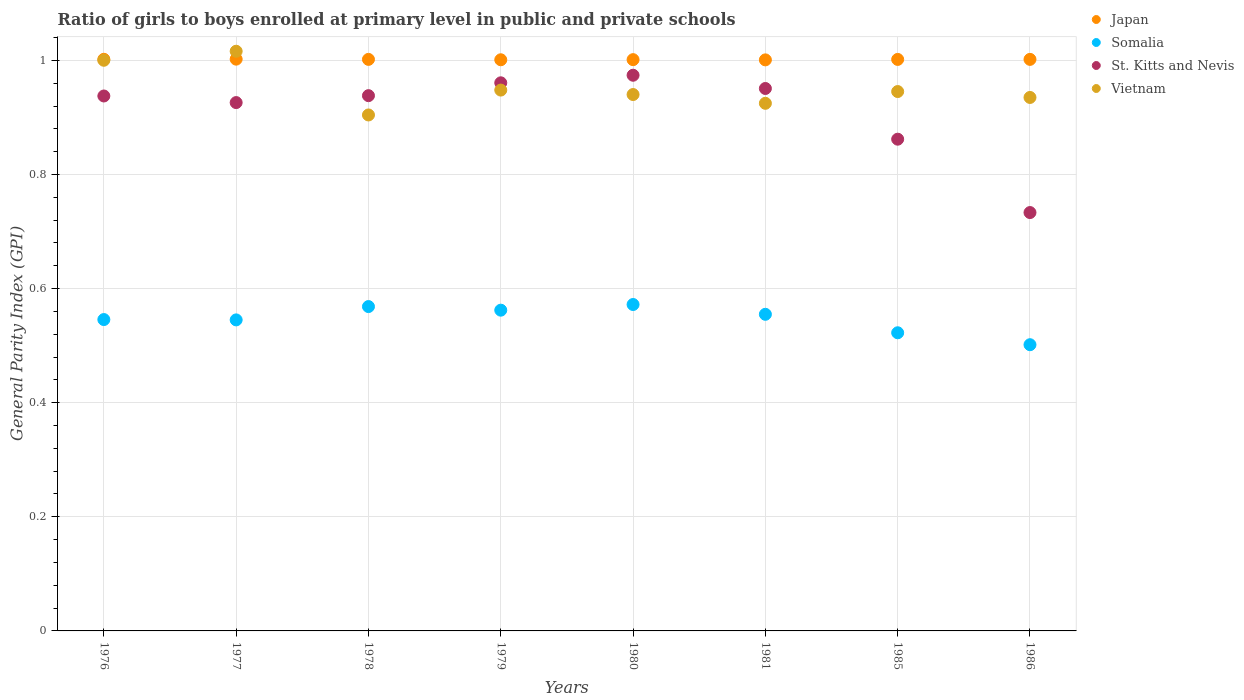How many different coloured dotlines are there?
Keep it short and to the point. 4. Is the number of dotlines equal to the number of legend labels?
Ensure brevity in your answer.  Yes. What is the general parity index in Somalia in 1986?
Give a very brief answer. 0.5. Across all years, what is the maximum general parity index in Vietnam?
Give a very brief answer. 1.02. Across all years, what is the minimum general parity index in Somalia?
Make the answer very short. 0.5. What is the total general parity index in Japan in the graph?
Ensure brevity in your answer.  8.01. What is the difference between the general parity index in Japan in 1977 and that in 1981?
Keep it short and to the point. 0. What is the difference between the general parity index in Vietnam in 1986 and the general parity index in Somalia in 1977?
Ensure brevity in your answer.  0.39. What is the average general parity index in Japan per year?
Offer a very short reply. 1. In the year 1980, what is the difference between the general parity index in Japan and general parity index in St. Kitts and Nevis?
Your answer should be very brief. 0.03. What is the ratio of the general parity index in Japan in 1980 to that in 1986?
Offer a terse response. 1. Is the difference between the general parity index in Japan in 1977 and 1986 greater than the difference between the general parity index in St. Kitts and Nevis in 1977 and 1986?
Offer a terse response. No. What is the difference between the highest and the second highest general parity index in Vietnam?
Keep it short and to the point. 0.02. What is the difference between the highest and the lowest general parity index in Vietnam?
Give a very brief answer. 0.11. Is the general parity index in Japan strictly greater than the general parity index in Vietnam over the years?
Make the answer very short. No. How many dotlines are there?
Keep it short and to the point. 4. Are the values on the major ticks of Y-axis written in scientific E-notation?
Your answer should be compact. No. Where does the legend appear in the graph?
Ensure brevity in your answer.  Top right. How are the legend labels stacked?
Ensure brevity in your answer.  Vertical. What is the title of the graph?
Your response must be concise. Ratio of girls to boys enrolled at primary level in public and private schools. Does "Mozambique" appear as one of the legend labels in the graph?
Offer a terse response. No. What is the label or title of the X-axis?
Offer a terse response. Years. What is the label or title of the Y-axis?
Keep it short and to the point. General Parity Index (GPI). What is the General Parity Index (GPI) of Japan in 1976?
Provide a short and direct response. 1. What is the General Parity Index (GPI) in Somalia in 1976?
Your answer should be compact. 0.55. What is the General Parity Index (GPI) in St. Kitts and Nevis in 1976?
Your response must be concise. 0.94. What is the General Parity Index (GPI) of Vietnam in 1976?
Your response must be concise. 1. What is the General Parity Index (GPI) of Japan in 1977?
Provide a succinct answer. 1. What is the General Parity Index (GPI) in Somalia in 1977?
Your answer should be very brief. 0.55. What is the General Parity Index (GPI) of St. Kitts and Nevis in 1977?
Offer a terse response. 0.93. What is the General Parity Index (GPI) of Vietnam in 1977?
Provide a succinct answer. 1.02. What is the General Parity Index (GPI) of Japan in 1978?
Keep it short and to the point. 1. What is the General Parity Index (GPI) in Somalia in 1978?
Your answer should be compact. 0.57. What is the General Parity Index (GPI) of St. Kitts and Nevis in 1978?
Provide a short and direct response. 0.94. What is the General Parity Index (GPI) of Vietnam in 1978?
Keep it short and to the point. 0.9. What is the General Parity Index (GPI) of Japan in 1979?
Make the answer very short. 1. What is the General Parity Index (GPI) of Somalia in 1979?
Give a very brief answer. 0.56. What is the General Parity Index (GPI) of St. Kitts and Nevis in 1979?
Provide a succinct answer. 0.96. What is the General Parity Index (GPI) of Vietnam in 1979?
Provide a short and direct response. 0.95. What is the General Parity Index (GPI) in Japan in 1980?
Offer a very short reply. 1. What is the General Parity Index (GPI) of Somalia in 1980?
Make the answer very short. 0.57. What is the General Parity Index (GPI) in St. Kitts and Nevis in 1980?
Your answer should be very brief. 0.97. What is the General Parity Index (GPI) of Vietnam in 1980?
Offer a terse response. 0.94. What is the General Parity Index (GPI) in Japan in 1981?
Provide a succinct answer. 1. What is the General Parity Index (GPI) of Somalia in 1981?
Your answer should be compact. 0.55. What is the General Parity Index (GPI) in St. Kitts and Nevis in 1981?
Keep it short and to the point. 0.95. What is the General Parity Index (GPI) in Vietnam in 1981?
Keep it short and to the point. 0.92. What is the General Parity Index (GPI) in Japan in 1985?
Provide a short and direct response. 1. What is the General Parity Index (GPI) of Somalia in 1985?
Keep it short and to the point. 0.52. What is the General Parity Index (GPI) of St. Kitts and Nevis in 1985?
Your response must be concise. 0.86. What is the General Parity Index (GPI) of Vietnam in 1985?
Offer a very short reply. 0.95. What is the General Parity Index (GPI) of Japan in 1986?
Your answer should be very brief. 1. What is the General Parity Index (GPI) in Somalia in 1986?
Make the answer very short. 0.5. What is the General Parity Index (GPI) of St. Kitts and Nevis in 1986?
Your answer should be compact. 0.73. What is the General Parity Index (GPI) in Vietnam in 1986?
Make the answer very short. 0.93. Across all years, what is the maximum General Parity Index (GPI) of Japan?
Keep it short and to the point. 1. Across all years, what is the maximum General Parity Index (GPI) in Somalia?
Your response must be concise. 0.57. Across all years, what is the maximum General Parity Index (GPI) of St. Kitts and Nevis?
Your response must be concise. 0.97. Across all years, what is the maximum General Parity Index (GPI) of Vietnam?
Your answer should be very brief. 1.02. Across all years, what is the minimum General Parity Index (GPI) in Japan?
Your response must be concise. 1. Across all years, what is the minimum General Parity Index (GPI) in Somalia?
Your answer should be very brief. 0.5. Across all years, what is the minimum General Parity Index (GPI) in St. Kitts and Nevis?
Your answer should be compact. 0.73. Across all years, what is the minimum General Parity Index (GPI) of Vietnam?
Your response must be concise. 0.9. What is the total General Parity Index (GPI) of Japan in the graph?
Keep it short and to the point. 8.01. What is the total General Parity Index (GPI) in Somalia in the graph?
Provide a short and direct response. 4.37. What is the total General Parity Index (GPI) of St. Kitts and Nevis in the graph?
Keep it short and to the point. 7.28. What is the total General Parity Index (GPI) in Vietnam in the graph?
Give a very brief answer. 7.61. What is the difference between the General Parity Index (GPI) in Japan in 1976 and that in 1977?
Offer a terse response. -0. What is the difference between the General Parity Index (GPI) of Somalia in 1976 and that in 1977?
Your answer should be compact. 0. What is the difference between the General Parity Index (GPI) of St. Kitts and Nevis in 1976 and that in 1977?
Provide a short and direct response. 0.01. What is the difference between the General Parity Index (GPI) in Vietnam in 1976 and that in 1977?
Ensure brevity in your answer.  -0.02. What is the difference between the General Parity Index (GPI) of Japan in 1976 and that in 1978?
Your response must be concise. 0. What is the difference between the General Parity Index (GPI) in Somalia in 1976 and that in 1978?
Offer a very short reply. -0.02. What is the difference between the General Parity Index (GPI) of St. Kitts and Nevis in 1976 and that in 1978?
Ensure brevity in your answer.  -0. What is the difference between the General Parity Index (GPI) in Vietnam in 1976 and that in 1978?
Provide a succinct answer. 0.1. What is the difference between the General Parity Index (GPI) of Japan in 1976 and that in 1979?
Offer a terse response. 0. What is the difference between the General Parity Index (GPI) in Somalia in 1976 and that in 1979?
Keep it short and to the point. -0.02. What is the difference between the General Parity Index (GPI) in St. Kitts and Nevis in 1976 and that in 1979?
Make the answer very short. -0.02. What is the difference between the General Parity Index (GPI) of Vietnam in 1976 and that in 1979?
Your response must be concise. 0.05. What is the difference between the General Parity Index (GPI) in Japan in 1976 and that in 1980?
Make the answer very short. 0. What is the difference between the General Parity Index (GPI) of Somalia in 1976 and that in 1980?
Keep it short and to the point. -0.03. What is the difference between the General Parity Index (GPI) in St. Kitts and Nevis in 1976 and that in 1980?
Give a very brief answer. -0.04. What is the difference between the General Parity Index (GPI) in Vietnam in 1976 and that in 1980?
Offer a very short reply. 0.06. What is the difference between the General Parity Index (GPI) in Somalia in 1976 and that in 1981?
Keep it short and to the point. -0.01. What is the difference between the General Parity Index (GPI) in St. Kitts and Nevis in 1976 and that in 1981?
Your answer should be very brief. -0.01. What is the difference between the General Parity Index (GPI) in Vietnam in 1976 and that in 1981?
Your answer should be compact. 0.08. What is the difference between the General Parity Index (GPI) of Japan in 1976 and that in 1985?
Give a very brief answer. 0. What is the difference between the General Parity Index (GPI) in Somalia in 1976 and that in 1985?
Give a very brief answer. 0.02. What is the difference between the General Parity Index (GPI) of St. Kitts and Nevis in 1976 and that in 1985?
Offer a terse response. 0.08. What is the difference between the General Parity Index (GPI) of Vietnam in 1976 and that in 1985?
Provide a short and direct response. 0.05. What is the difference between the General Parity Index (GPI) of Japan in 1976 and that in 1986?
Offer a terse response. 0. What is the difference between the General Parity Index (GPI) in Somalia in 1976 and that in 1986?
Provide a succinct answer. 0.04. What is the difference between the General Parity Index (GPI) of St. Kitts and Nevis in 1976 and that in 1986?
Provide a short and direct response. 0.2. What is the difference between the General Parity Index (GPI) of Vietnam in 1976 and that in 1986?
Give a very brief answer. 0.07. What is the difference between the General Parity Index (GPI) in Japan in 1977 and that in 1978?
Give a very brief answer. 0. What is the difference between the General Parity Index (GPI) in Somalia in 1977 and that in 1978?
Your answer should be compact. -0.02. What is the difference between the General Parity Index (GPI) in St. Kitts and Nevis in 1977 and that in 1978?
Provide a succinct answer. -0.01. What is the difference between the General Parity Index (GPI) in Vietnam in 1977 and that in 1978?
Provide a succinct answer. 0.11. What is the difference between the General Parity Index (GPI) in Japan in 1977 and that in 1979?
Your answer should be compact. 0. What is the difference between the General Parity Index (GPI) in Somalia in 1977 and that in 1979?
Your answer should be compact. -0.02. What is the difference between the General Parity Index (GPI) of St. Kitts and Nevis in 1977 and that in 1979?
Give a very brief answer. -0.03. What is the difference between the General Parity Index (GPI) of Vietnam in 1977 and that in 1979?
Keep it short and to the point. 0.07. What is the difference between the General Parity Index (GPI) in Japan in 1977 and that in 1980?
Give a very brief answer. 0. What is the difference between the General Parity Index (GPI) in Somalia in 1977 and that in 1980?
Your answer should be compact. -0.03. What is the difference between the General Parity Index (GPI) in St. Kitts and Nevis in 1977 and that in 1980?
Provide a short and direct response. -0.05. What is the difference between the General Parity Index (GPI) in Vietnam in 1977 and that in 1980?
Your response must be concise. 0.08. What is the difference between the General Parity Index (GPI) of Japan in 1977 and that in 1981?
Provide a short and direct response. 0. What is the difference between the General Parity Index (GPI) of Somalia in 1977 and that in 1981?
Provide a succinct answer. -0.01. What is the difference between the General Parity Index (GPI) of St. Kitts and Nevis in 1977 and that in 1981?
Your answer should be compact. -0.02. What is the difference between the General Parity Index (GPI) in Vietnam in 1977 and that in 1981?
Offer a very short reply. 0.09. What is the difference between the General Parity Index (GPI) in Somalia in 1977 and that in 1985?
Keep it short and to the point. 0.02. What is the difference between the General Parity Index (GPI) in St. Kitts and Nevis in 1977 and that in 1985?
Provide a short and direct response. 0.06. What is the difference between the General Parity Index (GPI) in Vietnam in 1977 and that in 1985?
Your answer should be compact. 0.07. What is the difference between the General Parity Index (GPI) in Somalia in 1977 and that in 1986?
Your response must be concise. 0.04. What is the difference between the General Parity Index (GPI) in St. Kitts and Nevis in 1977 and that in 1986?
Make the answer very short. 0.19. What is the difference between the General Parity Index (GPI) of Vietnam in 1977 and that in 1986?
Ensure brevity in your answer.  0.08. What is the difference between the General Parity Index (GPI) in Japan in 1978 and that in 1979?
Give a very brief answer. 0. What is the difference between the General Parity Index (GPI) of Somalia in 1978 and that in 1979?
Provide a short and direct response. 0.01. What is the difference between the General Parity Index (GPI) in St. Kitts and Nevis in 1978 and that in 1979?
Your answer should be compact. -0.02. What is the difference between the General Parity Index (GPI) of Vietnam in 1978 and that in 1979?
Provide a succinct answer. -0.04. What is the difference between the General Parity Index (GPI) of Somalia in 1978 and that in 1980?
Your answer should be compact. -0. What is the difference between the General Parity Index (GPI) of St. Kitts and Nevis in 1978 and that in 1980?
Provide a succinct answer. -0.04. What is the difference between the General Parity Index (GPI) of Vietnam in 1978 and that in 1980?
Provide a succinct answer. -0.04. What is the difference between the General Parity Index (GPI) of Japan in 1978 and that in 1981?
Your answer should be compact. 0. What is the difference between the General Parity Index (GPI) in Somalia in 1978 and that in 1981?
Offer a terse response. 0.01. What is the difference between the General Parity Index (GPI) of St. Kitts and Nevis in 1978 and that in 1981?
Keep it short and to the point. -0.01. What is the difference between the General Parity Index (GPI) in Vietnam in 1978 and that in 1981?
Offer a terse response. -0.02. What is the difference between the General Parity Index (GPI) in Somalia in 1978 and that in 1985?
Provide a succinct answer. 0.05. What is the difference between the General Parity Index (GPI) of St. Kitts and Nevis in 1978 and that in 1985?
Provide a short and direct response. 0.08. What is the difference between the General Parity Index (GPI) of Vietnam in 1978 and that in 1985?
Your answer should be compact. -0.04. What is the difference between the General Parity Index (GPI) in Japan in 1978 and that in 1986?
Give a very brief answer. -0. What is the difference between the General Parity Index (GPI) of Somalia in 1978 and that in 1986?
Keep it short and to the point. 0.07. What is the difference between the General Parity Index (GPI) of St. Kitts and Nevis in 1978 and that in 1986?
Offer a terse response. 0.2. What is the difference between the General Parity Index (GPI) in Vietnam in 1978 and that in 1986?
Provide a succinct answer. -0.03. What is the difference between the General Parity Index (GPI) of Japan in 1979 and that in 1980?
Offer a very short reply. -0. What is the difference between the General Parity Index (GPI) of Somalia in 1979 and that in 1980?
Provide a succinct answer. -0.01. What is the difference between the General Parity Index (GPI) in St. Kitts and Nevis in 1979 and that in 1980?
Your answer should be very brief. -0.01. What is the difference between the General Parity Index (GPI) of Vietnam in 1979 and that in 1980?
Your answer should be compact. 0.01. What is the difference between the General Parity Index (GPI) in Japan in 1979 and that in 1981?
Make the answer very short. 0. What is the difference between the General Parity Index (GPI) of Somalia in 1979 and that in 1981?
Ensure brevity in your answer.  0.01. What is the difference between the General Parity Index (GPI) in St. Kitts and Nevis in 1979 and that in 1981?
Your answer should be very brief. 0.01. What is the difference between the General Parity Index (GPI) of Vietnam in 1979 and that in 1981?
Your answer should be very brief. 0.02. What is the difference between the General Parity Index (GPI) of Japan in 1979 and that in 1985?
Make the answer very short. -0. What is the difference between the General Parity Index (GPI) in Somalia in 1979 and that in 1985?
Provide a short and direct response. 0.04. What is the difference between the General Parity Index (GPI) in St. Kitts and Nevis in 1979 and that in 1985?
Offer a terse response. 0.1. What is the difference between the General Parity Index (GPI) of Vietnam in 1979 and that in 1985?
Keep it short and to the point. 0. What is the difference between the General Parity Index (GPI) in Japan in 1979 and that in 1986?
Your answer should be very brief. -0. What is the difference between the General Parity Index (GPI) in Somalia in 1979 and that in 1986?
Make the answer very short. 0.06. What is the difference between the General Parity Index (GPI) of St. Kitts and Nevis in 1979 and that in 1986?
Give a very brief answer. 0.23. What is the difference between the General Parity Index (GPI) of Vietnam in 1979 and that in 1986?
Make the answer very short. 0.01. What is the difference between the General Parity Index (GPI) of Somalia in 1980 and that in 1981?
Make the answer very short. 0.02. What is the difference between the General Parity Index (GPI) of St. Kitts and Nevis in 1980 and that in 1981?
Your response must be concise. 0.02. What is the difference between the General Parity Index (GPI) of Vietnam in 1980 and that in 1981?
Give a very brief answer. 0.02. What is the difference between the General Parity Index (GPI) of Japan in 1980 and that in 1985?
Ensure brevity in your answer.  -0. What is the difference between the General Parity Index (GPI) in Somalia in 1980 and that in 1985?
Keep it short and to the point. 0.05. What is the difference between the General Parity Index (GPI) in St. Kitts and Nevis in 1980 and that in 1985?
Ensure brevity in your answer.  0.11. What is the difference between the General Parity Index (GPI) in Vietnam in 1980 and that in 1985?
Offer a terse response. -0.01. What is the difference between the General Parity Index (GPI) of Japan in 1980 and that in 1986?
Ensure brevity in your answer.  -0. What is the difference between the General Parity Index (GPI) of Somalia in 1980 and that in 1986?
Offer a terse response. 0.07. What is the difference between the General Parity Index (GPI) in St. Kitts and Nevis in 1980 and that in 1986?
Your answer should be very brief. 0.24. What is the difference between the General Parity Index (GPI) in Vietnam in 1980 and that in 1986?
Make the answer very short. 0.01. What is the difference between the General Parity Index (GPI) of Japan in 1981 and that in 1985?
Your response must be concise. -0. What is the difference between the General Parity Index (GPI) in Somalia in 1981 and that in 1985?
Provide a short and direct response. 0.03. What is the difference between the General Parity Index (GPI) in St. Kitts and Nevis in 1981 and that in 1985?
Keep it short and to the point. 0.09. What is the difference between the General Parity Index (GPI) of Vietnam in 1981 and that in 1985?
Your response must be concise. -0.02. What is the difference between the General Parity Index (GPI) in Japan in 1981 and that in 1986?
Provide a succinct answer. -0. What is the difference between the General Parity Index (GPI) of Somalia in 1981 and that in 1986?
Offer a very short reply. 0.05. What is the difference between the General Parity Index (GPI) of St. Kitts and Nevis in 1981 and that in 1986?
Keep it short and to the point. 0.22. What is the difference between the General Parity Index (GPI) in Vietnam in 1981 and that in 1986?
Keep it short and to the point. -0.01. What is the difference between the General Parity Index (GPI) in Japan in 1985 and that in 1986?
Give a very brief answer. -0. What is the difference between the General Parity Index (GPI) of Somalia in 1985 and that in 1986?
Give a very brief answer. 0.02. What is the difference between the General Parity Index (GPI) of St. Kitts and Nevis in 1985 and that in 1986?
Provide a succinct answer. 0.13. What is the difference between the General Parity Index (GPI) of Vietnam in 1985 and that in 1986?
Your answer should be very brief. 0.01. What is the difference between the General Parity Index (GPI) in Japan in 1976 and the General Parity Index (GPI) in Somalia in 1977?
Give a very brief answer. 0.46. What is the difference between the General Parity Index (GPI) of Japan in 1976 and the General Parity Index (GPI) of St. Kitts and Nevis in 1977?
Your response must be concise. 0.08. What is the difference between the General Parity Index (GPI) of Japan in 1976 and the General Parity Index (GPI) of Vietnam in 1977?
Provide a short and direct response. -0.01. What is the difference between the General Parity Index (GPI) of Somalia in 1976 and the General Parity Index (GPI) of St. Kitts and Nevis in 1977?
Give a very brief answer. -0.38. What is the difference between the General Parity Index (GPI) in Somalia in 1976 and the General Parity Index (GPI) in Vietnam in 1977?
Keep it short and to the point. -0.47. What is the difference between the General Parity Index (GPI) in St. Kitts and Nevis in 1976 and the General Parity Index (GPI) in Vietnam in 1977?
Offer a very short reply. -0.08. What is the difference between the General Parity Index (GPI) in Japan in 1976 and the General Parity Index (GPI) in Somalia in 1978?
Provide a short and direct response. 0.43. What is the difference between the General Parity Index (GPI) of Japan in 1976 and the General Parity Index (GPI) of St. Kitts and Nevis in 1978?
Your response must be concise. 0.06. What is the difference between the General Parity Index (GPI) in Japan in 1976 and the General Parity Index (GPI) in Vietnam in 1978?
Your answer should be very brief. 0.1. What is the difference between the General Parity Index (GPI) of Somalia in 1976 and the General Parity Index (GPI) of St. Kitts and Nevis in 1978?
Provide a short and direct response. -0.39. What is the difference between the General Parity Index (GPI) in Somalia in 1976 and the General Parity Index (GPI) in Vietnam in 1978?
Give a very brief answer. -0.36. What is the difference between the General Parity Index (GPI) of St. Kitts and Nevis in 1976 and the General Parity Index (GPI) of Vietnam in 1978?
Keep it short and to the point. 0.03. What is the difference between the General Parity Index (GPI) in Japan in 1976 and the General Parity Index (GPI) in Somalia in 1979?
Provide a succinct answer. 0.44. What is the difference between the General Parity Index (GPI) of Japan in 1976 and the General Parity Index (GPI) of St. Kitts and Nevis in 1979?
Ensure brevity in your answer.  0.04. What is the difference between the General Parity Index (GPI) in Japan in 1976 and the General Parity Index (GPI) in Vietnam in 1979?
Your response must be concise. 0.05. What is the difference between the General Parity Index (GPI) in Somalia in 1976 and the General Parity Index (GPI) in St. Kitts and Nevis in 1979?
Keep it short and to the point. -0.41. What is the difference between the General Parity Index (GPI) of Somalia in 1976 and the General Parity Index (GPI) of Vietnam in 1979?
Provide a short and direct response. -0.4. What is the difference between the General Parity Index (GPI) in St. Kitts and Nevis in 1976 and the General Parity Index (GPI) in Vietnam in 1979?
Ensure brevity in your answer.  -0.01. What is the difference between the General Parity Index (GPI) of Japan in 1976 and the General Parity Index (GPI) of Somalia in 1980?
Your response must be concise. 0.43. What is the difference between the General Parity Index (GPI) in Japan in 1976 and the General Parity Index (GPI) in St. Kitts and Nevis in 1980?
Provide a succinct answer. 0.03. What is the difference between the General Parity Index (GPI) in Japan in 1976 and the General Parity Index (GPI) in Vietnam in 1980?
Your answer should be very brief. 0.06. What is the difference between the General Parity Index (GPI) in Somalia in 1976 and the General Parity Index (GPI) in St. Kitts and Nevis in 1980?
Make the answer very short. -0.43. What is the difference between the General Parity Index (GPI) of Somalia in 1976 and the General Parity Index (GPI) of Vietnam in 1980?
Make the answer very short. -0.39. What is the difference between the General Parity Index (GPI) in St. Kitts and Nevis in 1976 and the General Parity Index (GPI) in Vietnam in 1980?
Ensure brevity in your answer.  -0. What is the difference between the General Parity Index (GPI) in Japan in 1976 and the General Parity Index (GPI) in Somalia in 1981?
Provide a succinct answer. 0.45. What is the difference between the General Parity Index (GPI) of Japan in 1976 and the General Parity Index (GPI) of St. Kitts and Nevis in 1981?
Your response must be concise. 0.05. What is the difference between the General Parity Index (GPI) in Japan in 1976 and the General Parity Index (GPI) in Vietnam in 1981?
Your answer should be very brief. 0.08. What is the difference between the General Parity Index (GPI) of Somalia in 1976 and the General Parity Index (GPI) of St. Kitts and Nevis in 1981?
Offer a terse response. -0.41. What is the difference between the General Parity Index (GPI) in Somalia in 1976 and the General Parity Index (GPI) in Vietnam in 1981?
Offer a very short reply. -0.38. What is the difference between the General Parity Index (GPI) in St. Kitts and Nevis in 1976 and the General Parity Index (GPI) in Vietnam in 1981?
Provide a succinct answer. 0.01. What is the difference between the General Parity Index (GPI) in Japan in 1976 and the General Parity Index (GPI) in Somalia in 1985?
Make the answer very short. 0.48. What is the difference between the General Parity Index (GPI) of Japan in 1976 and the General Parity Index (GPI) of St. Kitts and Nevis in 1985?
Offer a terse response. 0.14. What is the difference between the General Parity Index (GPI) of Japan in 1976 and the General Parity Index (GPI) of Vietnam in 1985?
Offer a very short reply. 0.06. What is the difference between the General Parity Index (GPI) in Somalia in 1976 and the General Parity Index (GPI) in St. Kitts and Nevis in 1985?
Your response must be concise. -0.32. What is the difference between the General Parity Index (GPI) of Somalia in 1976 and the General Parity Index (GPI) of Vietnam in 1985?
Make the answer very short. -0.4. What is the difference between the General Parity Index (GPI) of St. Kitts and Nevis in 1976 and the General Parity Index (GPI) of Vietnam in 1985?
Offer a terse response. -0.01. What is the difference between the General Parity Index (GPI) of Japan in 1976 and the General Parity Index (GPI) of Somalia in 1986?
Your answer should be compact. 0.5. What is the difference between the General Parity Index (GPI) of Japan in 1976 and the General Parity Index (GPI) of St. Kitts and Nevis in 1986?
Your response must be concise. 0.27. What is the difference between the General Parity Index (GPI) of Japan in 1976 and the General Parity Index (GPI) of Vietnam in 1986?
Offer a terse response. 0.07. What is the difference between the General Parity Index (GPI) of Somalia in 1976 and the General Parity Index (GPI) of St. Kitts and Nevis in 1986?
Ensure brevity in your answer.  -0.19. What is the difference between the General Parity Index (GPI) of Somalia in 1976 and the General Parity Index (GPI) of Vietnam in 1986?
Make the answer very short. -0.39. What is the difference between the General Parity Index (GPI) of St. Kitts and Nevis in 1976 and the General Parity Index (GPI) of Vietnam in 1986?
Offer a terse response. 0. What is the difference between the General Parity Index (GPI) in Japan in 1977 and the General Parity Index (GPI) in Somalia in 1978?
Provide a short and direct response. 0.43. What is the difference between the General Parity Index (GPI) in Japan in 1977 and the General Parity Index (GPI) in St. Kitts and Nevis in 1978?
Provide a short and direct response. 0.06. What is the difference between the General Parity Index (GPI) in Japan in 1977 and the General Parity Index (GPI) in Vietnam in 1978?
Give a very brief answer. 0.1. What is the difference between the General Parity Index (GPI) in Somalia in 1977 and the General Parity Index (GPI) in St. Kitts and Nevis in 1978?
Offer a terse response. -0.39. What is the difference between the General Parity Index (GPI) in Somalia in 1977 and the General Parity Index (GPI) in Vietnam in 1978?
Offer a terse response. -0.36. What is the difference between the General Parity Index (GPI) in St. Kitts and Nevis in 1977 and the General Parity Index (GPI) in Vietnam in 1978?
Your answer should be very brief. 0.02. What is the difference between the General Parity Index (GPI) in Japan in 1977 and the General Parity Index (GPI) in Somalia in 1979?
Ensure brevity in your answer.  0.44. What is the difference between the General Parity Index (GPI) of Japan in 1977 and the General Parity Index (GPI) of St. Kitts and Nevis in 1979?
Offer a terse response. 0.04. What is the difference between the General Parity Index (GPI) in Japan in 1977 and the General Parity Index (GPI) in Vietnam in 1979?
Your answer should be very brief. 0.05. What is the difference between the General Parity Index (GPI) in Somalia in 1977 and the General Parity Index (GPI) in St. Kitts and Nevis in 1979?
Offer a terse response. -0.42. What is the difference between the General Parity Index (GPI) in Somalia in 1977 and the General Parity Index (GPI) in Vietnam in 1979?
Offer a very short reply. -0.4. What is the difference between the General Parity Index (GPI) in St. Kitts and Nevis in 1977 and the General Parity Index (GPI) in Vietnam in 1979?
Provide a short and direct response. -0.02. What is the difference between the General Parity Index (GPI) of Japan in 1977 and the General Parity Index (GPI) of Somalia in 1980?
Offer a very short reply. 0.43. What is the difference between the General Parity Index (GPI) of Japan in 1977 and the General Parity Index (GPI) of St. Kitts and Nevis in 1980?
Keep it short and to the point. 0.03. What is the difference between the General Parity Index (GPI) of Japan in 1977 and the General Parity Index (GPI) of Vietnam in 1980?
Offer a terse response. 0.06. What is the difference between the General Parity Index (GPI) of Somalia in 1977 and the General Parity Index (GPI) of St. Kitts and Nevis in 1980?
Provide a short and direct response. -0.43. What is the difference between the General Parity Index (GPI) of Somalia in 1977 and the General Parity Index (GPI) of Vietnam in 1980?
Keep it short and to the point. -0.4. What is the difference between the General Parity Index (GPI) of St. Kitts and Nevis in 1977 and the General Parity Index (GPI) of Vietnam in 1980?
Your answer should be compact. -0.01. What is the difference between the General Parity Index (GPI) in Japan in 1977 and the General Parity Index (GPI) in Somalia in 1981?
Your answer should be compact. 0.45. What is the difference between the General Parity Index (GPI) of Japan in 1977 and the General Parity Index (GPI) of St. Kitts and Nevis in 1981?
Provide a succinct answer. 0.05. What is the difference between the General Parity Index (GPI) in Japan in 1977 and the General Parity Index (GPI) in Vietnam in 1981?
Keep it short and to the point. 0.08. What is the difference between the General Parity Index (GPI) in Somalia in 1977 and the General Parity Index (GPI) in St. Kitts and Nevis in 1981?
Offer a terse response. -0.41. What is the difference between the General Parity Index (GPI) of Somalia in 1977 and the General Parity Index (GPI) of Vietnam in 1981?
Your answer should be compact. -0.38. What is the difference between the General Parity Index (GPI) of St. Kitts and Nevis in 1977 and the General Parity Index (GPI) of Vietnam in 1981?
Your answer should be compact. 0. What is the difference between the General Parity Index (GPI) in Japan in 1977 and the General Parity Index (GPI) in Somalia in 1985?
Provide a succinct answer. 0.48. What is the difference between the General Parity Index (GPI) in Japan in 1977 and the General Parity Index (GPI) in St. Kitts and Nevis in 1985?
Provide a succinct answer. 0.14. What is the difference between the General Parity Index (GPI) of Japan in 1977 and the General Parity Index (GPI) of Vietnam in 1985?
Offer a terse response. 0.06. What is the difference between the General Parity Index (GPI) in Somalia in 1977 and the General Parity Index (GPI) in St. Kitts and Nevis in 1985?
Your response must be concise. -0.32. What is the difference between the General Parity Index (GPI) of Somalia in 1977 and the General Parity Index (GPI) of Vietnam in 1985?
Your response must be concise. -0.4. What is the difference between the General Parity Index (GPI) in St. Kitts and Nevis in 1977 and the General Parity Index (GPI) in Vietnam in 1985?
Provide a short and direct response. -0.02. What is the difference between the General Parity Index (GPI) of Japan in 1977 and the General Parity Index (GPI) of Somalia in 1986?
Ensure brevity in your answer.  0.5. What is the difference between the General Parity Index (GPI) in Japan in 1977 and the General Parity Index (GPI) in St. Kitts and Nevis in 1986?
Give a very brief answer. 0.27. What is the difference between the General Parity Index (GPI) of Japan in 1977 and the General Parity Index (GPI) of Vietnam in 1986?
Give a very brief answer. 0.07. What is the difference between the General Parity Index (GPI) of Somalia in 1977 and the General Parity Index (GPI) of St. Kitts and Nevis in 1986?
Keep it short and to the point. -0.19. What is the difference between the General Parity Index (GPI) in Somalia in 1977 and the General Parity Index (GPI) in Vietnam in 1986?
Give a very brief answer. -0.39. What is the difference between the General Parity Index (GPI) of St. Kitts and Nevis in 1977 and the General Parity Index (GPI) of Vietnam in 1986?
Your response must be concise. -0.01. What is the difference between the General Parity Index (GPI) of Japan in 1978 and the General Parity Index (GPI) of Somalia in 1979?
Make the answer very short. 0.44. What is the difference between the General Parity Index (GPI) of Japan in 1978 and the General Parity Index (GPI) of St. Kitts and Nevis in 1979?
Give a very brief answer. 0.04. What is the difference between the General Parity Index (GPI) in Japan in 1978 and the General Parity Index (GPI) in Vietnam in 1979?
Offer a terse response. 0.05. What is the difference between the General Parity Index (GPI) in Somalia in 1978 and the General Parity Index (GPI) in St. Kitts and Nevis in 1979?
Your response must be concise. -0.39. What is the difference between the General Parity Index (GPI) of Somalia in 1978 and the General Parity Index (GPI) of Vietnam in 1979?
Provide a short and direct response. -0.38. What is the difference between the General Parity Index (GPI) of St. Kitts and Nevis in 1978 and the General Parity Index (GPI) of Vietnam in 1979?
Your answer should be very brief. -0.01. What is the difference between the General Parity Index (GPI) in Japan in 1978 and the General Parity Index (GPI) in Somalia in 1980?
Provide a succinct answer. 0.43. What is the difference between the General Parity Index (GPI) in Japan in 1978 and the General Parity Index (GPI) in St. Kitts and Nevis in 1980?
Make the answer very short. 0.03. What is the difference between the General Parity Index (GPI) in Japan in 1978 and the General Parity Index (GPI) in Vietnam in 1980?
Your response must be concise. 0.06. What is the difference between the General Parity Index (GPI) in Somalia in 1978 and the General Parity Index (GPI) in St. Kitts and Nevis in 1980?
Make the answer very short. -0.41. What is the difference between the General Parity Index (GPI) in Somalia in 1978 and the General Parity Index (GPI) in Vietnam in 1980?
Make the answer very short. -0.37. What is the difference between the General Parity Index (GPI) in St. Kitts and Nevis in 1978 and the General Parity Index (GPI) in Vietnam in 1980?
Your response must be concise. -0. What is the difference between the General Parity Index (GPI) of Japan in 1978 and the General Parity Index (GPI) of Somalia in 1981?
Give a very brief answer. 0.45. What is the difference between the General Parity Index (GPI) of Japan in 1978 and the General Parity Index (GPI) of St. Kitts and Nevis in 1981?
Provide a succinct answer. 0.05. What is the difference between the General Parity Index (GPI) in Japan in 1978 and the General Parity Index (GPI) in Vietnam in 1981?
Your answer should be compact. 0.08. What is the difference between the General Parity Index (GPI) of Somalia in 1978 and the General Parity Index (GPI) of St. Kitts and Nevis in 1981?
Offer a very short reply. -0.38. What is the difference between the General Parity Index (GPI) of Somalia in 1978 and the General Parity Index (GPI) of Vietnam in 1981?
Your answer should be compact. -0.36. What is the difference between the General Parity Index (GPI) of St. Kitts and Nevis in 1978 and the General Parity Index (GPI) of Vietnam in 1981?
Give a very brief answer. 0.01. What is the difference between the General Parity Index (GPI) in Japan in 1978 and the General Parity Index (GPI) in Somalia in 1985?
Keep it short and to the point. 0.48. What is the difference between the General Parity Index (GPI) of Japan in 1978 and the General Parity Index (GPI) of St. Kitts and Nevis in 1985?
Offer a terse response. 0.14. What is the difference between the General Parity Index (GPI) of Japan in 1978 and the General Parity Index (GPI) of Vietnam in 1985?
Your answer should be very brief. 0.06. What is the difference between the General Parity Index (GPI) of Somalia in 1978 and the General Parity Index (GPI) of St. Kitts and Nevis in 1985?
Keep it short and to the point. -0.29. What is the difference between the General Parity Index (GPI) in Somalia in 1978 and the General Parity Index (GPI) in Vietnam in 1985?
Provide a succinct answer. -0.38. What is the difference between the General Parity Index (GPI) in St. Kitts and Nevis in 1978 and the General Parity Index (GPI) in Vietnam in 1985?
Make the answer very short. -0.01. What is the difference between the General Parity Index (GPI) of Japan in 1978 and the General Parity Index (GPI) of Somalia in 1986?
Offer a terse response. 0.5. What is the difference between the General Parity Index (GPI) of Japan in 1978 and the General Parity Index (GPI) of St. Kitts and Nevis in 1986?
Offer a terse response. 0.27. What is the difference between the General Parity Index (GPI) in Japan in 1978 and the General Parity Index (GPI) in Vietnam in 1986?
Give a very brief answer. 0.07. What is the difference between the General Parity Index (GPI) of Somalia in 1978 and the General Parity Index (GPI) of St. Kitts and Nevis in 1986?
Your answer should be very brief. -0.16. What is the difference between the General Parity Index (GPI) of Somalia in 1978 and the General Parity Index (GPI) of Vietnam in 1986?
Offer a terse response. -0.37. What is the difference between the General Parity Index (GPI) of St. Kitts and Nevis in 1978 and the General Parity Index (GPI) of Vietnam in 1986?
Your answer should be very brief. 0. What is the difference between the General Parity Index (GPI) of Japan in 1979 and the General Parity Index (GPI) of Somalia in 1980?
Ensure brevity in your answer.  0.43. What is the difference between the General Parity Index (GPI) in Japan in 1979 and the General Parity Index (GPI) in St. Kitts and Nevis in 1980?
Your answer should be compact. 0.03. What is the difference between the General Parity Index (GPI) in Japan in 1979 and the General Parity Index (GPI) in Vietnam in 1980?
Provide a short and direct response. 0.06. What is the difference between the General Parity Index (GPI) of Somalia in 1979 and the General Parity Index (GPI) of St. Kitts and Nevis in 1980?
Provide a succinct answer. -0.41. What is the difference between the General Parity Index (GPI) in Somalia in 1979 and the General Parity Index (GPI) in Vietnam in 1980?
Keep it short and to the point. -0.38. What is the difference between the General Parity Index (GPI) in St. Kitts and Nevis in 1979 and the General Parity Index (GPI) in Vietnam in 1980?
Offer a very short reply. 0.02. What is the difference between the General Parity Index (GPI) in Japan in 1979 and the General Parity Index (GPI) in Somalia in 1981?
Your answer should be compact. 0.45. What is the difference between the General Parity Index (GPI) of Japan in 1979 and the General Parity Index (GPI) of St. Kitts and Nevis in 1981?
Your response must be concise. 0.05. What is the difference between the General Parity Index (GPI) in Japan in 1979 and the General Parity Index (GPI) in Vietnam in 1981?
Your answer should be very brief. 0.08. What is the difference between the General Parity Index (GPI) of Somalia in 1979 and the General Parity Index (GPI) of St. Kitts and Nevis in 1981?
Provide a succinct answer. -0.39. What is the difference between the General Parity Index (GPI) of Somalia in 1979 and the General Parity Index (GPI) of Vietnam in 1981?
Ensure brevity in your answer.  -0.36. What is the difference between the General Parity Index (GPI) in St. Kitts and Nevis in 1979 and the General Parity Index (GPI) in Vietnam in 1981?
Offer a terse response. 0.04. What is the difference between the General Parity Index (GPI) in Japan in 1979 and the General Parity Index (GPI) in Somalia in 1985?
Keep it short and to the point. 0.48. What is the difference between the General Parity Index (GPI) of Japan in 1979 and the General Parity Index (GPI) of St. Kitts and Nevis in 1985?
Make the answer very short. 0.14. What is the difference between the General Parity Index (GPI) of Japan in 1979 and the General Parity Index (GPI) of Vietnam in 1985?
Keep it short and to the point. 0.06. What is the difference between the General Parity Index (GPI) of Somalia in 1979 and the General Parity Index (GPI) of St. Kitts and Nevis in 1985?
Your response must be concise. -0.3. What is the difference between the General Parity Index (GPI) of Somalia in 1979 and the General Parity Index (GPI) of Vietnam in 1985?
Ensure brevity in your answer.  -0.38. What is the difference between the General Parity Index (GPI) of St. Kitts and Nevis in 1979 and the General Parity Index (GPI) of Vietnam in 1985?
Offer a terse response. 0.02. What is the difference between the General Parity Index (GPI) of Japan in 1979 and the General Parity Index (GPI) of Somalia in 1986?
Your response must be concise. 0.5. What is the difference between the General Parity Index (GPI) in Japan in 1979 and the General Parity Index (GPI) in St. Kitts and Nevis in 1986?
Provide a succinct answer. 0.27. What is the difference between the General Parity Index (GPI) in Japan in 1979 and the General Parity Index (GPI) in Vietnam in 1986?
Your answer should be very brief. 0.07. What is the difference between the General Parity Index (GPI) of Somalia in 1979 and the General Parity Index (GPI) of St. Kitts and Nevis in 1986?
Give a very brief answer. -0.17. What is the difference between the General Parity Index (GPI) of Somalia in 1979 and the General Parity Index (GPI) of Vietnam in 1986?
Ensure brevity in your answer.  -0.37. What is the difference between the General Parity Index (GPI) in St. Kitts and Nevis in 1979 and the General Parity Index (GPI) in Vietnam in 1986?
Your response must be concise. 0.03. What is the difference between the General Parity Index (GPI) in Japan in 1980 and the General Parity Index (GPI) in Somalia in 1981?
Your answer should be compact. 0.45. What is the difference between the General Parity Index (GPI) of Japan in 1980 and the General Parity Index (GPI) of St. Kitts and Nevis in 1981?
Offer a very short reply. 0.05. What is the difference between the General Parity Index (GPI) of Japan in 1980 and the General Parity Index (GPI) of Vietnam in 1981?
Your answer should be compact. 0.08. What is the difference between the General Parity Index (GPI) of Somalia in 1980 and the General Parity Index (GPI) of St. Kitts and Nevis in 1981?
Provide a succinct answer. -0.38. What is the difference between the General Parity Index (GPI) in Somalia in 1980 and the General Parity Index (GPI) in Vietnam in 1981?
Keep it short and to the point. -0.35. What is the difference between the General Parity Index (GPI) in St. Kitts and Nevis in 1980 and the General Parity Index (GPI) in Vietnam in 1981?
Your answer should be very brief. 0.05. What is the difference between the General Parity Index (GPI) in Japan in 1980 and the General Parity Index (GPI) in Somalia in 1985?
Give a very brief answer. 0.48. What is the difference between the General Parity Index (GPI) in Japan in 1980 and the General Parity Index (GPI) in St. Kitts and Nevis in 1985?
Provide a succinct answer. 0.14. What is the difference between the General Parity Index (GPI) in Japan in 1980 and the General Parity Index (GPI) in Vietnam in 1985?
Keep it short and to the point. 0.06. What is the difference between the General Parity Index (GPI) of Somalia in 1980 and the General Parity Index (GPI) of St. Kitts and Nevis in 1985?
Provide a short and direct response. -0.29. What is the difference between the General Parity Index (GPI) of Somalia in 1980 and the General Parity Index (GPI) of Vietnam in 1985?
Your answer should be compact. -0.37. What is the difference between the General Parity Index (GPI) in St. Kitts and Nevis in 1980 and the General Parity Index (GPI) in Vietnam in 1985?
Your answer should be compact. 0.03. What is the difference between the General Parity Index (GPI) in Japan in 1980 and the General Parity Index (GPI) in Somalia in 1986?
Ensure brevity in your answer.  0.5. What is the difference between the General Parity Index (GPI) of Japan in 1980 and the General Parity Index (GPI) of St. Kitts and Nevis in 1986?
Keep it short and to the point. 0.27. What is the difference between the General Parity Index (GPI) of Japan in 1980 and the General Parity Index (GPI) of Vietnam in 1986?
Your response must be concise. 0.07. What is the difference between the General Parity Index (GPI) in Somalia in 1980 and the General Parity Index (GPI) in St. Kitts and Nevis in 1986?
Provide a succinct answer. -0.16. What is the difference between the General Parity Index (GPI) in Somalia in 1980 and the General Parity Index (GPI) in Vietnam in 1986?
Your response must be concise. -0.36. What is the difference between the General Parity Index (GPI) of St. Kitts and Nevis in 1980 and the General Parity Index (GPI) of Vietnam in 1986?
Offer a very short reply. 0.04. What is the difference between the General Parity Index (GPI) of Japan in 1981 and the General Parity Index (GPI) of Somalia in 1985?
Give a very brief answer. 0.48. What is the difference between the General Parity Index (GPI) in Japan in 1981 and the General Parity Index (GPI) in St. Kitts and Nevis in 1985?
Make the answer very short. 0.14. What is the difference between the General Parity Index (GPI) of Japan in 1981 and the General Parity Index (GPI) of Vietnam in 1985?
Provide a short and direct response. 0.06. What is the difference between the General Parity Index (GPI) of Somalia in 1981 and the General Parity Index (GPI) of St. Kitts and Nevis in 1985?
Ensure brevity in your answer.  -0.31. What is the difference between the General Parity Index (GPI) in Somalia in 1981 and the General Parity Index (GPI) in Vietnam in 1985?
Provide a succinct answer. -0.39. What is the difference between the General Parity Index (GPI) of St. Kitts and Nevis in 1981 and the General Parity Index (GPI) of Vietnam in 1985?
Offer a terse response. 0.01. What is the difference between the General Parity Index (GPI) of Japan in 1981 and the General Parity Index (GPI) of Somalia in 1986?
Your answer should be compact. 0.5. What is the difference between the General Parity Index (GPI) of Japan in 1981 and the General Parity Index (GPI) of St. Kitts and Nevis in 1986?
Make the answer very short. 0.27. What is the difference between the General Parity Index (GPI) of Japan in 1981 and the General Parity Index (GPI) of Vietnam in 1986?
Give a very brief answer. 0.07. What is the difference between the General Parity Index (GPI) in Somalia in 1981 and the General Parity Index (GPI) in St. Kitts and Nevis in 1986?
Give a very brief answer. -0.18. What is the difference between the General Parity Index (GPI) in Somalia in 1981 and the General Parity Index (GPI) in Vietnam in 1986?
Keep it short and to the point. -0.38. What is the difference between the General Parity Index (GPI) of St. Kitts and Nevis in 1981 and the General Parity Index (GPI) of Vietnam in 1986?
Offer a terse response. 0.02. What is the difference between the General Parity Index (GPI) in Japan in 1985 and the General Parity Index (GPI) in Somalia in 1986?
Ensure brevity in your answer.  0.5. What is the difference between the General Parity Index (GPI) in Japan in 1985 and the General Parity Index (GPI) in St. Kitts and Nevis in 1986?
Your answer should be compact. 0.27. What is the difference between the General Parity Index (GPI) of Japan in 1985 and the General Parity Index (GPI) of Vietnam in 1986?
Ensure brevity in your answer.  0.07. What is the difference between the General Parity Index (GPI) in Somalia in 1985 and the General Parity Index (GPI) in St. Kitts and Nevis in 1986?
Give a very brief answer. -0.21. What is the difference between the General Parity Index (GPI) in Somalia in 1985 and the General Parity Index (GPI) in Vietnam in 1986?
Give a very brief answer. -0.41. What is the difference between the General Parity Index (GPI) of St. Kitts and Nevis in 1985 and the General Parity Index (GPI) of Vietnam in 1986?
Give a very brief answer. -0.07. What is the average General Parity Index (GPI) in Japan per year?
Ensure brevity in your answer.  1. What is the average General Parity Index (GPI) of Somalia per year?
Offer a very short reply. 0.55. What is the average General Parity Index (GPI) of St. Kitts and Nevis per year?
Ensure brevity in your answer.  0.91. What is the average General Parity Index (GPI) of Vietnam per year?
Make the answer very short. 0.95. In the year 1976, what is the difference between the General Parity Index (GPI) of Japan and General Parity Index (GPI) of Somalia?
Your answer should be very brief. 0.46. In the year 1976, what is the difference between the General Parity Index (GPI) in Japan and General Parity Index (GPI) in St. Kitts and Nevis?
Make the answer very short. 0.06. In the year 1976, what is the difference between the General Parity Index (GPI) in Japan and General Parity Index (GPI) in Vietnam?
Ensure brevity in your answer.  0. In the year 1976, what is the difference between the General Parity Index (GPI) in Somalia and General Parity Index (GPI) in St. Kitts and Nevis?
Ensure brevity in your answer.  -0.39. In the year 1976, what is the difference between the General Parity Index (GPI) of Somalia and General Parity Index (GPI) of Vietnam?
Ensure brevity in your answer.  -0.45. In the year 1976, what is the difference between the General Parity Index (GPI) of St. Kitts and Nevis and General Parity Index (GPI) of Vietnam?
Your answer should be very brief. -0.06. In the year 1977, what is the difference between the General Parity Index (GPI) of Japan and General Parity Index (GPI) of Somalia?
Offer a very short reply. 0.46. In the year 1977, what is the difference between the General Parity Index (GPI) in Japan and General Parity Index (GPI) in St. Kitts and Nevis?
Provide a short and direct response. 0.08. In the year 1977, what is the difference between the General Parity Index (GPI) of Japan and General Parity Index (GPI) of Vietnam?
Keep it short and to the point. -0.01. In the year 1977, what is the difference between the General Parity Index (GPI) in Somalia and General Parity Index (GPI) in St. Kitts and Nevis?
Your answer should be compact. -0.38. In the year 1977, what is the difference between the General Parity Index (GPI) in Somalia and General Parity Index (GPI) in Vietnam?
Give a very brief answer. -0.47. In the year 1977, what is the difference between the General Parity Index (GPI) in St. Kitts and Nevis and General Parity Index (GPI) in Vietnam?
Offer a terse response. -0.09. In the year 1978, what is the difference between the General Parity Index (GPI) of Japan and General Parity Index (GPI) of Somalia?
Keep it short and to the point. 0.43. In the year 1978, what is the difference between the General Parity Index (GPI) of Japan and General Parity Index (GPI) of St. Kitts and Nevis?
Offer a very short reply. 0.06. In the year 1978, what is the difference between the General Parity Index (GPI) of Japan and General Parity Index (GPI) of Vietnam?
Provide a succinct answer. 0.1. In the year 1978, what is the difference between the General Parity Index (GPI) of Somalia and General Parity Index (GPI) of St. Kitts and Nevis?
Keep it short and to the point. -0.37. In the year 1978, what is the difference between the General Parity Index (GPI) in Somalia and General Parity Index (GPI) in Vietnam?
Your answer should be very brief. -0.34. In the year 1978, what is the difference between the General Parity Index (GPI) of St. Kitts and Nevis and General Parity Index (GPI) of Vietnam?
Keep it short and to the point. 0.03. In the year 1979, what is the difference between the General Parity Index (GPI) of Japan and General Parity Index (GPI) of Somalia?
Ensure brevity in your answer.  0.44. In the year 1979, what is the difference between the General Parity Index (GPI) in Japan and General Parity Index (GPI) in St. Kitts and Nevis?
Offer a very short reply. 0.04. In the year 1979, what is the difference between the General Parity Index (GPI) in Japan and General Parity Index (GPI) in Vietnam?
Your response must be concise. 0.05. In the year 1979, what is the difference between the General Parity Index (GPI) in Somalia and General Parity Index (GPI) in St. Kitts and Nevis?
Provide a short and direct response. -0.4. In the year 1979, what is the difference between the General Parity Index (GPI) in Somalia and General Parity Index (GPI) in Vietnam?
Provide a short and direct response. -0.39. In the year 1979, what is the difference between the General Parity Index (GPI) in St. Kitts and Nevis and General Parity Index (GPI) in Vietnam?
Your response must be concise. 0.01. In the year 1980, what is the difference between the General Parity Index (GPI) in Japan and General Parity Index (GPI) in Somalia?
Ensure brevity in your answer.  0.43. In the year 1980, what is the difference between the General Parity Index (GPI) in Japan and General Parity Index (GPI) in St. Kitts and Nevis?
Ensure brevity in your answer.  0.03. In the year 1980, what is the difference between the General Parity Index (GPI) of Japan and General Parity Index (GPI) of Vietnam?
Provide a succinct answer. 0.06. In the year 1980, what is the difference between the General Parity Index (GPI) in Somalia and General Parity Index (GPI) in St. Kitts and Nevis?
Make the answer very short. -0.4. In the year 1980, what is the difference between the General Parity Index (GPI) in Somalia and General Parity Index (GPI) in Vietnam?
Your response must be concise. -0.37. In the year 1980, what is the difference between the General Parity Index (GPI) of St. Kitts and Nevis and General Parity Index (GPI) of Vietnam?
Your answer should be very brief. 0.03. In the year 1981, what is the difference between the General Parity Index (GPI) of Japan and General Parity Index (GPI) of Somalia?
Offer a terse response. 0.45. In the year 1981, what is the difference between the General Parity Index (GPI) of Japan and General Parity Index (GPI) of St. Kitts and Nevis?
Keep it short and to the point. 0.05. In the year 1981, what is the difference between the General Parity Index (GPI) in Japan and General Parity Index (GPI) in Vietnam?
Offer a very short reply. 0.08. In the year 1981, what is the difference between the General Parity Index (GPI) in Somalia and General Parity Index (GPI) in St. Kitts and Nevis?
Give a very brief answer. -0.4. In the year 1981, what is the difference between the General Parity Index (GPI) of Somalia and General Parity Index (GPI) of Vietnam?
Offer a terse response. -0.37. In the year 1981, what is the difference between the General Parity Index (GPI) of St. Kitts and Nevis and General Parity Index (GPI) of Vietnam?
Your answer should be very brief. 0.03. In the year 1985, what is the difference between the General Parity Index (GPI) of Japan and General Parity Index (GPI) of Somalia?
Make the answer very short. 0.48. In the year 1985, what is the difference between the General Parity Index (GPI) in Japan and General Parity Index (GPI) in St. Kitts and Nevis?
Ensure brevity in your answer.  0.14. In the year 1985, what is the difference between the General Parity Index (GPI) of Japan and General Parity Index (GPI) of Vietnam?
Offer a terse response. 0.06. In the year 1985, what is the difference between the General Parity Index (GPI) of Somalia and General Parity Index (GPI) of St. Kitts and Nevis?
Your response must be concise. -0.34. In the year 1985, what is the difference between the General Parity Index (GPI) of Somalia and General Parity Index (GPI) of Vietnam?
Make the answer very short. -0.42. In the year 1985, what is the difference between the General Parity Index (GPI) of St. Kitts and Nevis and General Parity Index (GPI) of Vietnam?
Offer a very short reply. -0.08. In the year 1986, what is the difference between the General Parity Index (GPI) of Japan and General Parity Index (GPI) of Somalia?
Ensure brevity in your answer.  0.5. In the year 1986, what is the difference between the General Parity Index (GPI) of Japan and General Parity Index (GPI) of St. Kitts and Nevis?
Your answer should be very brief. 0.27. In the year 1986, what is the difference between the General Parity Index (GPI) in Japan and General Parity Index (GPI) in Vietnam?
Provide a succinct answer. 0.07. In the year 1986, what is the difference between the General Parity Index (GPI) of Somalia and General Parity Index (GPI) of St. Kitts and Nevis?
Keep it short and to the point. -0.23. In the year 1986, what is the difference between the General Parity Index (GPI) in Somalia and General Parity Index (GPI) in Vietnam?
Offer a terse response. -0.43. In the year 1986, what is the difference between the General Parity Index (GPI) of St. Kitts and Nevis and General Parity Index (GPI) of Vietnam?
Your answer should be compact. -0.2. What is the ratio of the General Parity Index (GPI) in Japan in 1976 to that in 1977?
Your answer should be compact. 1. What is the ratio of the General Parity Index (GPI) in St. Kitts and Nevis in 1976 to that in 1977?
Ensure brevity in your answer.  1.01. What is the ratio of the General Parity Index (GPI) in Vietnam in 1976 to that in 1977?
Offer a very short reply. 0.98. What is the ratio of the General Parity Index (GPI) in Japan in 1976 to that in 1978?
Your answer should be compact. 1. What is the ratio of the General Parity Index (GPI) of Somalia in 1976 to that in 1978?
Offer a terse response. 0.96. What is the ratio of the General Parity Index (GPI) of Vietnam in 1976 to that in 1978?
Give a very brief answer. 1.11. What is the ratio of the General Parity Index (GPI) of Japan in 1976 to that in 1979?
Give a very brief answer. 1. What is the ratio of the General Parity Index (GPI) in Somalia in 1976 to that in 1979?
Make the answer very short. 0.97. What is the ratio of the General Parity Index (GPI) in Vietnam in 1976 to that in 1979?
Keep it short and to the point. 1.06. What is the ratio of the General Parity Index (GPI) of Japan in 1976 to that in 1980?
Give a very brief answer. 1. What is the ratio of the General Parity Index (GPI) of Somalia in 1976 to that in 1980?
Keep it short and to the point. 0.95. What is the ratio of the General Parity Index (GPI) in St. Kitts and Nevis in 1976 to that in 1980?
Ensure brevity in your answer.  0.96. What is the ratio of the General Parity Index (GPI) of Vietnam in 1976 to that in 1980?
Give a very brief answer. 1.06. What is the ratio of the General Parity Index (GPI) in Somalia in 1976 to that in 1981?
Provide a succinct answer. 0.98. What is the ratio of the General Parity Index (GPI) of St. Kitts and Nevis in 1976 to that in 1981?
Give a very brief answer. 0.99. What is the ratio of the General Parity Index (GPI) of Vietnam in 1976 to that in 1981?
Your response must be concise. 1.08. What is the ratio of the General Parity Index (GPI) of Somalia in 1976 to that in 1985?
Keep it short and to the point. 1.04. What is the ratio of the General Parity Index (GPI) of St. Kitts and Nevis in 1976 to that in 1985?
Make the answer very short. 1.09. What is the ratio of the General Parity Index (GPI) of Vietnam in 1976 to that in 1985?
Make the answer very short. 1.06. What is the ratio of the General Parity Index (GPI) of Japan in 1976 to that in 1986?
Your answer should be compact. 1. What is the ratio of the General Parity Index (GPI) of Somalia in 1976 to that in 1986?
Make the answer very short. 1.09. What is the ratio of the General Parity Index (GPI) of St. Kitts and Nevis in 1976 to that in 1986?
Ensure brevity in your answer.  1.28. What is the ratio of the General Parity Index (GPI) of Vietnam in 1976 to that in 1986?
Make the answer very short. 1.07. What is the ratio of the General Parity Index (GPI) of Japan in 1977 to that in 1978?
Provide a succinct answer. 1. What is the ratio of the General Parity Index (GPI) in Somalia in 1977 to that in 1978?
Provide a succinct answer. 0.96. What is the ratio of the General Parity Index (GPI) of St. Kitts and Nevis in 1977 to that in 1978?
Provide a succinct answer. 0.99. What is the ratio of the General Parity Index (GPI) in Vietnam in 1977 to that in 1978?
Give a very brief answer. 1.12. What is the ratio of the General Parity Index (GPI) of Japan in 1977 to that in 1979?
Offer a very short reply. 1. What is the ratio of the General Parity Index (GPI) of Somalia in 1977 to that in 1979?
Your answer should be very brief. 0.97. What is the ratio of the General Parity Index (GPI) in St. Kitts and Nevis in 1977 to that in 1979?
Provide a short and direct response. 0.96. What is the ratio of the General Parity Index (GPI) in Vietnam in 1977 to that in 1979?
Your response must be concise. 1.07. What is the ratio of the General Parity Index (GPI) in Japan in 1977 to that in 1980?
Provide a short and direct response. 1. What is the ratio of the General Parity Index (GPI) of Somalia in 1977 to that in 1980?
Make the answer very short. 0.95. What is the ratio of the General Parity Index (GPI) of St. Kitts and Nevis in 1977 to that in 1980?
Offer a terse response. 0.95. What is the ratio of the General Parity Index (GPI) of Vietnam in 1977 to that in 1980?
Offer a terse response. 1.08. What is the ratio of the General Parity Index (GPI) of Somalia in 1977 to that in 1981?
Your answer should be compact. 0.98. What is the ratio of the General Parity Index (GPI) of Vietnam in 1977 to that in 1981?
Your response must be concise. 1.1. What is the ratio of the General Parity Index (GPI) in Japan in 1977 to that in 1985?
Keep it short and to the point. 1. What is the ratio of the General Parity Index (GPI) in Somalia in 1977 to that in 1985?
Keep it short and to the point. 1.04. What is the ratio of the General Parity Index (GPI) of St. Kitts and Nevis in 1977 to that in 1985?
Provide a short and direct response. 1.07. What is the ratio of the General Parity Index (GPI) in Vietnam in 1977 to that in 1985?
Provide a succinct answer. 1.07. What is the ratio of the General Parity Index (GPI) in Somalia in 1977 to that in 1986?
Keep it short and to the point. 1.09. What is the ratio of the General Parity Index (GPI) of St. Kitts and Nevis in 1977 to that in 1986?
Make the answer very short. 1.26. What is the ratio of the General Parity Index (GPI) of Vietnam in 1977 to that in 1986?
Ensure brevity in your answer.  1.09. What is the ratio of the General Parity Index (GPI) of Somalia in 1978 to that in 1979?
Your answer should be compact. 1.01. What is the ratio of the General Parity Index (GPI) in St. Kitts and Nevis in 1978 to that in 1979?
Give a very brief answer. 0.98. What is the ratio of the General Parity Index (GPI) in Vietnam in 1978 to that in 1979?
Give a very brief answer. 0.95. What is the ratio of the General Parity Index (GPI) in Japan in 1978 to that in 1980?
Provide a short and direct response. 1. What is the ratio of the General Parity Index (GPI) in St. Kitts and Nevis in 1978 to that in 1980?
Ensure brevity in your answer.  0.96. What is the ratio of the General Parity Index (GPI) of Vietnam in 1978 to that in 1980?
Offer a very short reply. 0.96. What is the ratio of the General Parity Index (GPI) of Japan in 1978 to that in 1981?
Ensure brevity in your answer.  1. What is the ratio of the General Parity Index (GPI) of Somalia in 1978 to that in 1981?
Make the answer very short. 1.02. What is the ratio of the General Parity Index (GPI) of St. Kitts and Nevis in 1978 to that in 1981?
Your response must be concise. 0.99. What is the ratio of the General Parity Index (GPI) in Vietnam in 1978 to that in 1981?
Ensure brevity in your answer.  0.98. What is the ratio of the General Parity Index (GPI) of Japan in 1978 to that in 1985?
Your answer should be compact. 1. What is the ratio of the General Parity Index (GPI) in Somalia in 1978 to that in 1985?
Your answer should be very brief. 1.09. What is the ratio of the General Parity Index (GPI) of St. Kitts and Nevis in 1978 to that in 1985?
Give a very brief answer. 1.09. What is the ratio of the General Parity Index (GPI) in Vietnam in 1978 to that in 1985?
Give a very brief answer. 0.96. What is the ratio of the General Parity Index (GPI) in Somalia in 1978 to that in 1986?
Make the answer very short. 1.13. What is the ratio of the General Parity Index (GPI) of St. Kitts and Nevis in 1978 to that in 1986?
Provide a short and direct response. 1.28. What is the ratio of the General Parity Index (GPI) of Vietnam in 1978 to that in 1986?
Your answer should be compact. 0.97. What is the ratio of the General Parity Index (GPI) of Somalia in 1979 to that in 1980?
Your answer should be compact. 0.98. What is the ratio of the General Parity Index (GPI) in St. Kitts and Nevis in 1979 to that in 1980?
Ensure brevity in your answer.  0.99. What is the ratio of the General Parity Index (GPI) of Vietnam in 1979 to that in 1980?
Ensure brevity in your answer.  1.01. What is the ratio of the General Parity Index (GPI) in St. Kitts and Nevis in 1979 to that in 1981?
Your response must be concise. 1.01. What is the ratio of the General Parity Index (GPI) in Vietnam in 1979 to that in 1981?
Keep it short and to the point. 1.03. What is the ratio of the General Parity Index (GPI) in Japan in 1979 to that in 1985?
Your response must be concise. 1. What is the ratio of the General Parity Index (GPI) of Somalia in 1979 to that in 1985?
Offer a terse response. 1.08. What is the ratio of the General Parity Index (GPI) in St. Kitts and Nevis in 1979 to that in 1985?
Provide a short and direct response. 1.11. What is the ratio of the General Parity Index (GPI) in Japan in 1979 to that in 1986?
Provide a short and direct response. 1. What is the ratio of the General Parity Index (GPI) in Somalia in 1979 to that in 1986?
Keep it short and to the point. 1.12. What is the ratio of the General Parity Index (GPI) in St. Kitts and Nevis in 1979 to that in 1986?
Offer a very short reply. 1.31. What is the ratio of the General Parity Index (GPI) of Vietnam in 1979 to that in 1986?
Give a very brief answer. 1.01. What is the ratio of the General Parity Index (GPI) in Somalia in 1980 to that in 1981?
Ensure brevity in your answer.  1.03. What is the ratio of the General Parity Index (GPI) in St. Kitts and Nevis in 1980 to that in 1981?
Keep it short and to the point. 1.02. What is the ratio of the General Parity Index (GPI) in Vietnam in 1980 to that in 1981?
Your answer should be compact. 1.02. What is the ratio of the General Parity Index (GPI) in Japan in 1980 to that in 1985?
Your response must be concise. 1. What is the ratio of the General Parity Index (GPI) in Somalia in 1980 to that in 1985?
Offer a very short reply. 1.09. What is the ratio of the General Parity Index (GPI) of St. Kitts and Nevis in 1980 to that in 1985?
Provide a short and direct response. 1.13. What is the ratio of the General Parity Index (GPI) in Vietnam in 1980 to that in 1985?
Provide a short and direct response. 0.99. What is the ratio of the General Parity Index (GPI) in Somalia in 1980 to that in 1986?
Keep it short and to the point. 1.14. What is the ratio of the General Parity Index (GPI) in St. Kitts and Nevis in 1980 to that in 1986?
Make the answer very short. 1.33. What is the ratio of the General Parity Index (GPI) of Somalia in 1981 to that in 1985?
Your answer should be compact. 1.06. What is the ratio of the General Parity Index (GPI) in St. Kitts and Nevis in 1981 to that in 1985?
Make the answer very short. 1.1. What is the ratio of the General Parity Index (GPI) in Vietnam in 1981 to that in 1985?
Give a very brief answer. 0.98. What is the ratio of the General Parity Index (GPI) in Somalia in 1981 to that in 1986?
Your response must be concise. 1.11. What is the ratio of the General Parity Index (GPI) in St. Kitts and Nevis in 1981 to that in 1986?
Make the answer very short. 1.3. What is the ratio of the General Parity Index (GPI) of Japan in 1985 to that in 1986?
Your answer should be compact. 1. What is the ratio of the General Parity Index (GPI) of Somalia in 1985 to that in 1986?
Give a very brief answer. 1.04. What is the ratio of the General Parity Index (GPI) of St. Kitts and Nevis in 1985 to that in 1986?
Your answer should be compact. 1.18. What is the ratio of the General Parity Index (GPI) of Vietnam in 1985 to that in 1986?
Give a very brief answer. 1.01. What is the difference between the highest and the second highest General Parity Index (GPI) of Somalia?
Your response must be concise. 0. What is the difference between the highest and the second highest General Parity Index (GPI) of St. Kitts and Nevis?
Offer a very short reply. 0.01. What is the difference between the highest and the second highest General Parity Index (GPI) in Vietnam?
Ensure brevity in your answer.  0.02. What is the difference between the highest and the lowest General Parity Index (GPI) of Japan?
Give a very brief answer. 0. What is the difference between the highest and the lowest General Parity Index (GPI) in Somalia?
Offer a very short reply. 0.07. What is the difference between the highest and the lowest General Parity Index (GPI) in St. Kitts and Nevis?
Offer a very short reply. 0.24. What is the difference between the highest and the lowest General Parity Index (GPI) in Vietnam?
Your answer should be very brief. 0.11. 